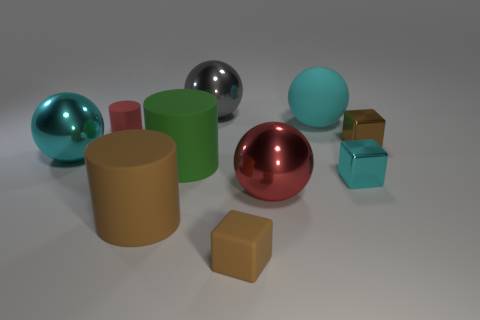What is the shape of the small brown object in front of the cyan thing that is in front of the big cyan metal object?
Your answer should be very brief. Cube. Are there the same number of tiny cyan shiny cubes that are in front of the tiny cyan thing and spheres?
Give a very brief answer. No. What is the material of the cyan sphere that is right of the large cyan thing that is on the left side of the large matte object in front of the big red shiny ball?
Ensure brevity in your answer.  Rubber. Is there a cyan metal thing of the same size as the green rubber cylinder?
Keep it short and to the point. Yes. What is the shape of the large cyan metal thing?
Provide a short and direct response. Sphere. How many blocks are tiny shiny things or red things?
Provide a succinct answer. 2. Are there the same number of cyan blocks that are in front of the tiny brown rubber object and rubber cylinders in front of the big cyan metal object?
Offer a very short reply. No. How many brown things are to the left of the small brown cube that is in front of the object to the left of the small red rubber cylinder?
Ensure brevity in your answer.  1. There is a big thing that is the same color as the big rubber sphere; what shape is it?
Make the answer very short. Sphere. Does the small cylinder have the same color as the metallic sphere right of the brown rubber cube?
Provide a short and direct response. Yes. 